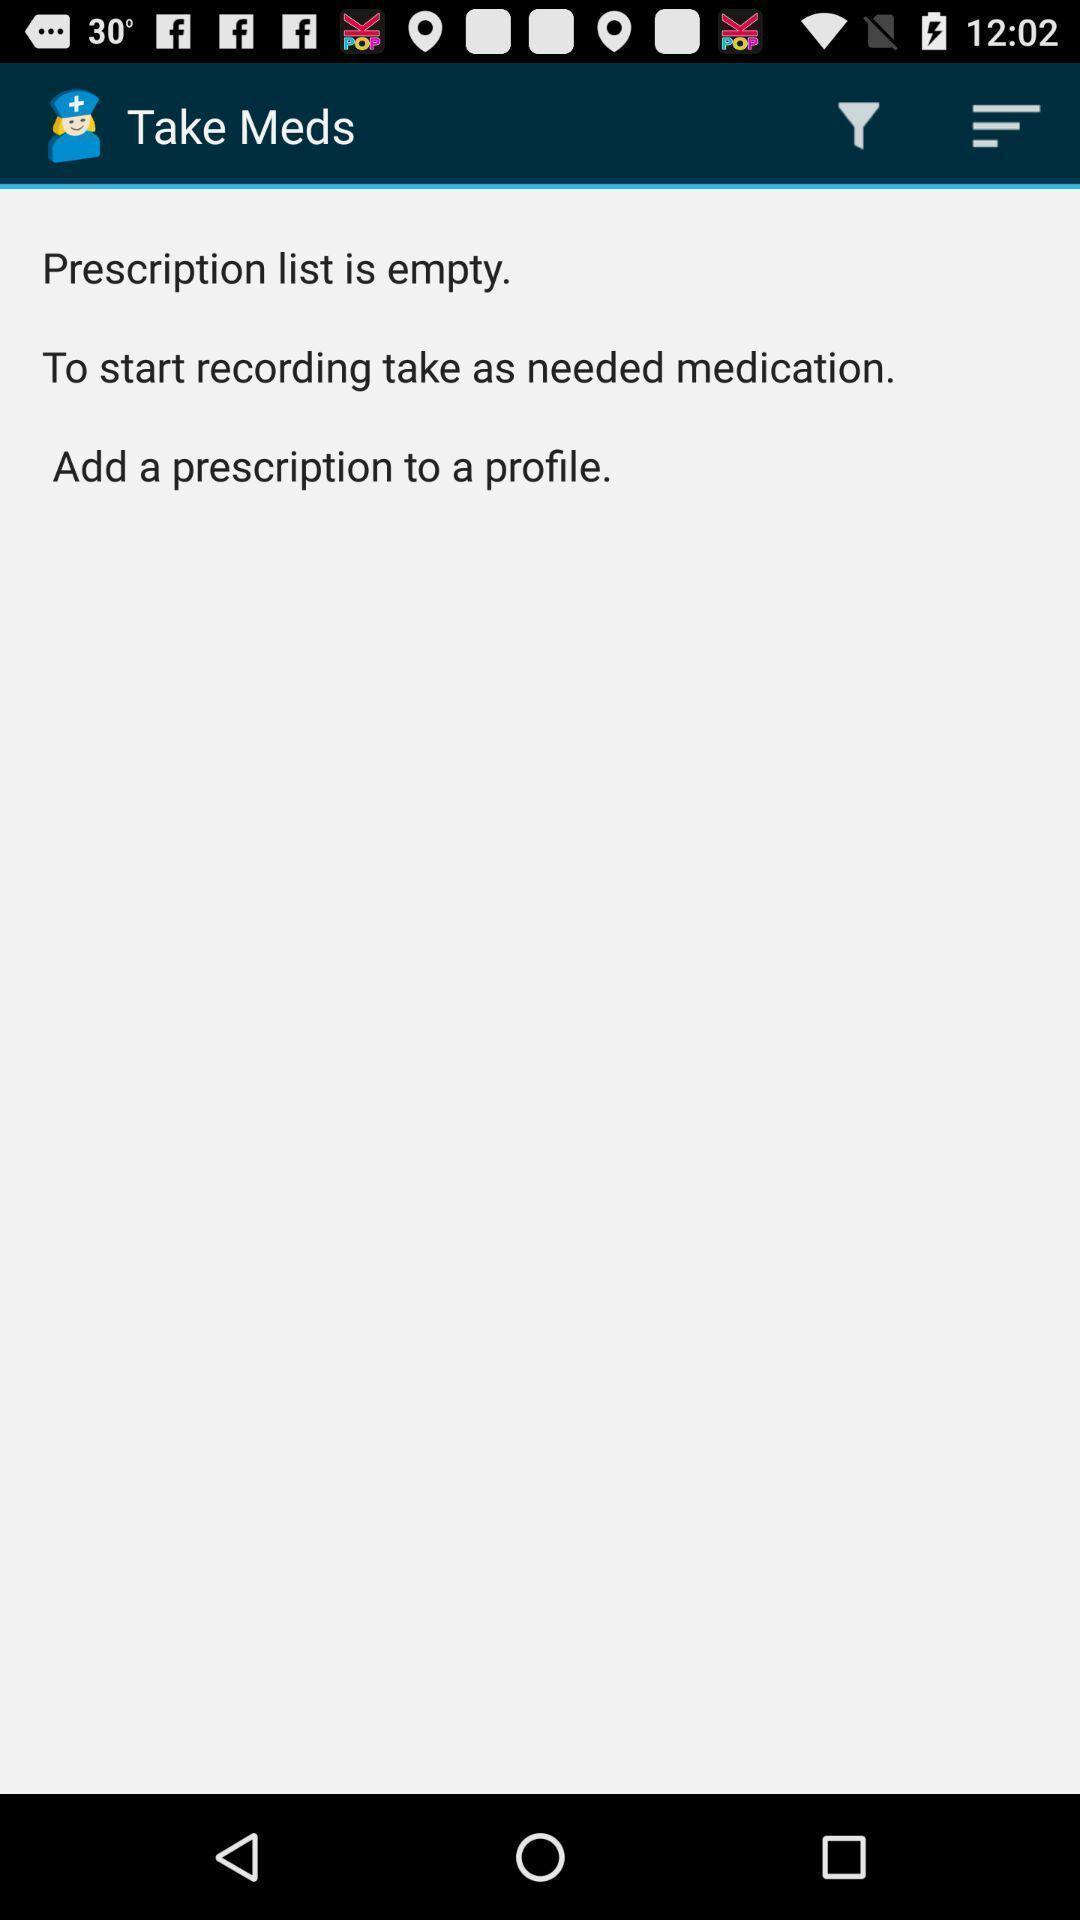Explain the elements present in this screenshot. Screen page displaying prescription status in health application. 